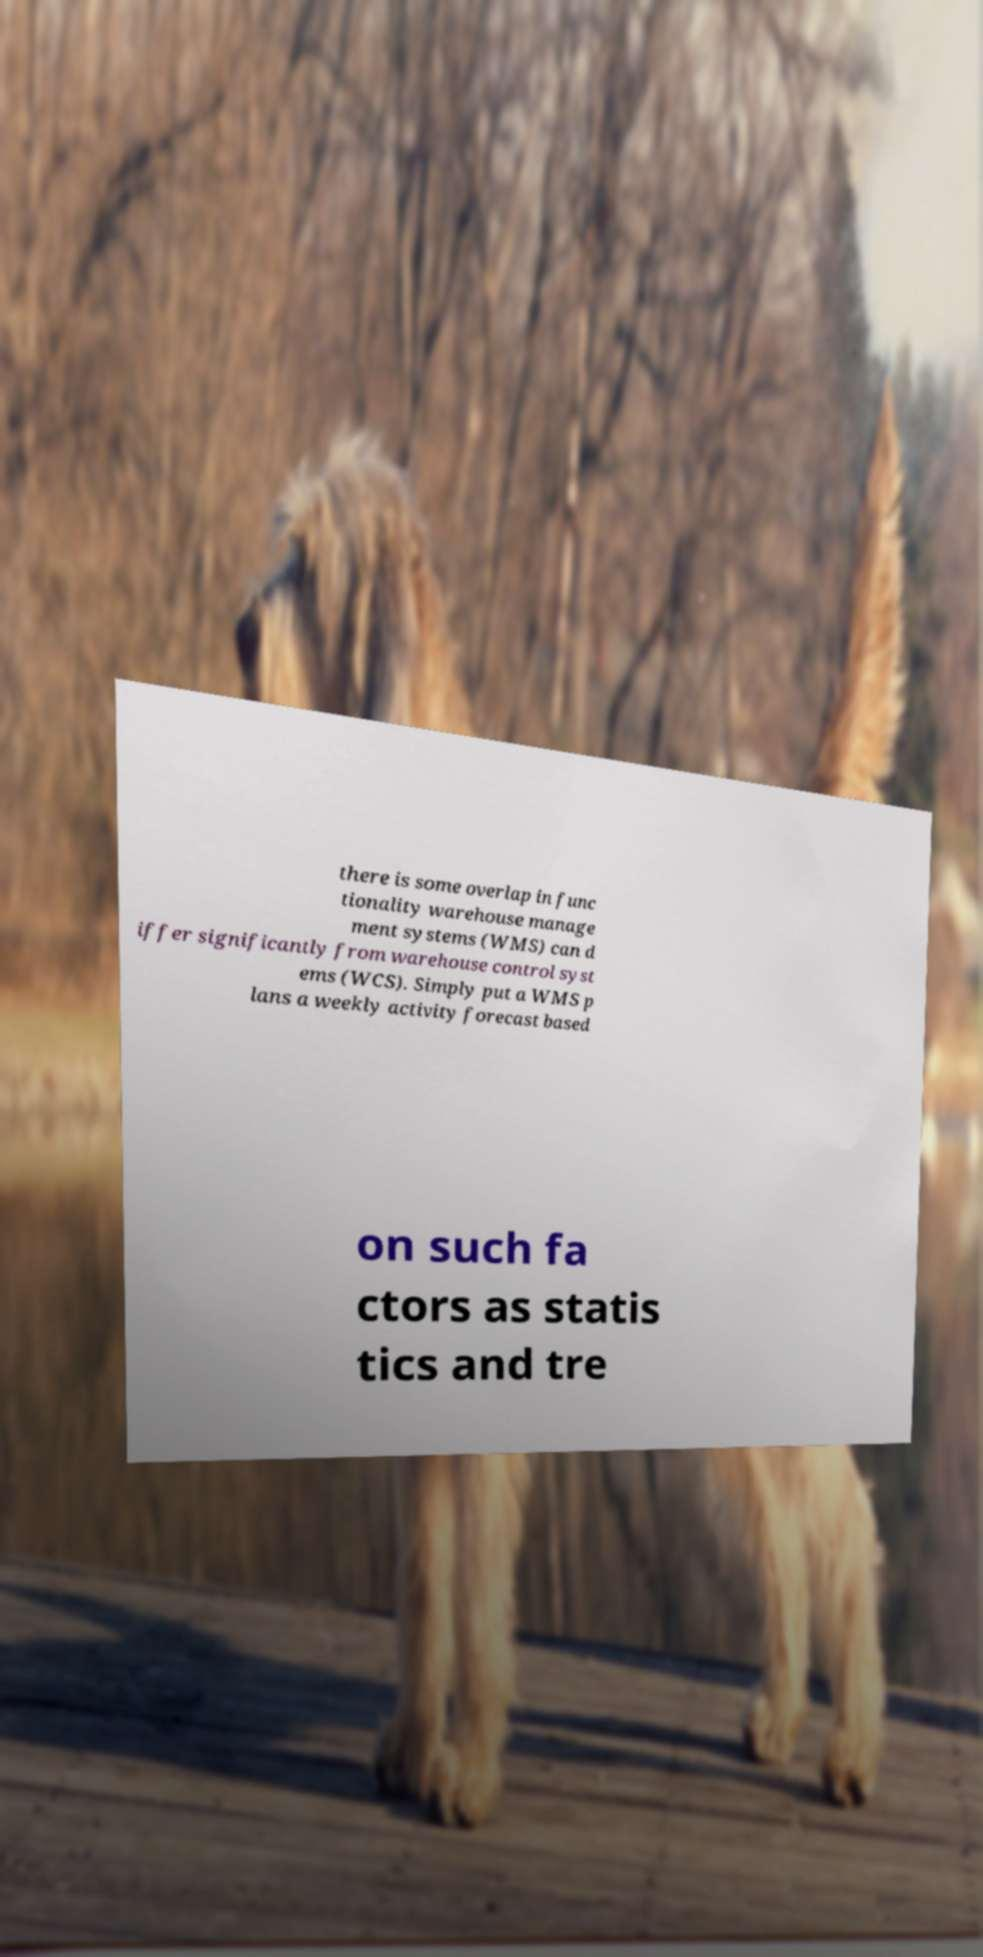Could you extract and type out the text from this image? there is some overlap in func tionality warehouse manage ment systems (WMS) can d iffer significantly from warehouse control syst ems (WCS). Simply put a WMS p lans a weekly activity forecast based on such fa ctors as statis tics and tre 